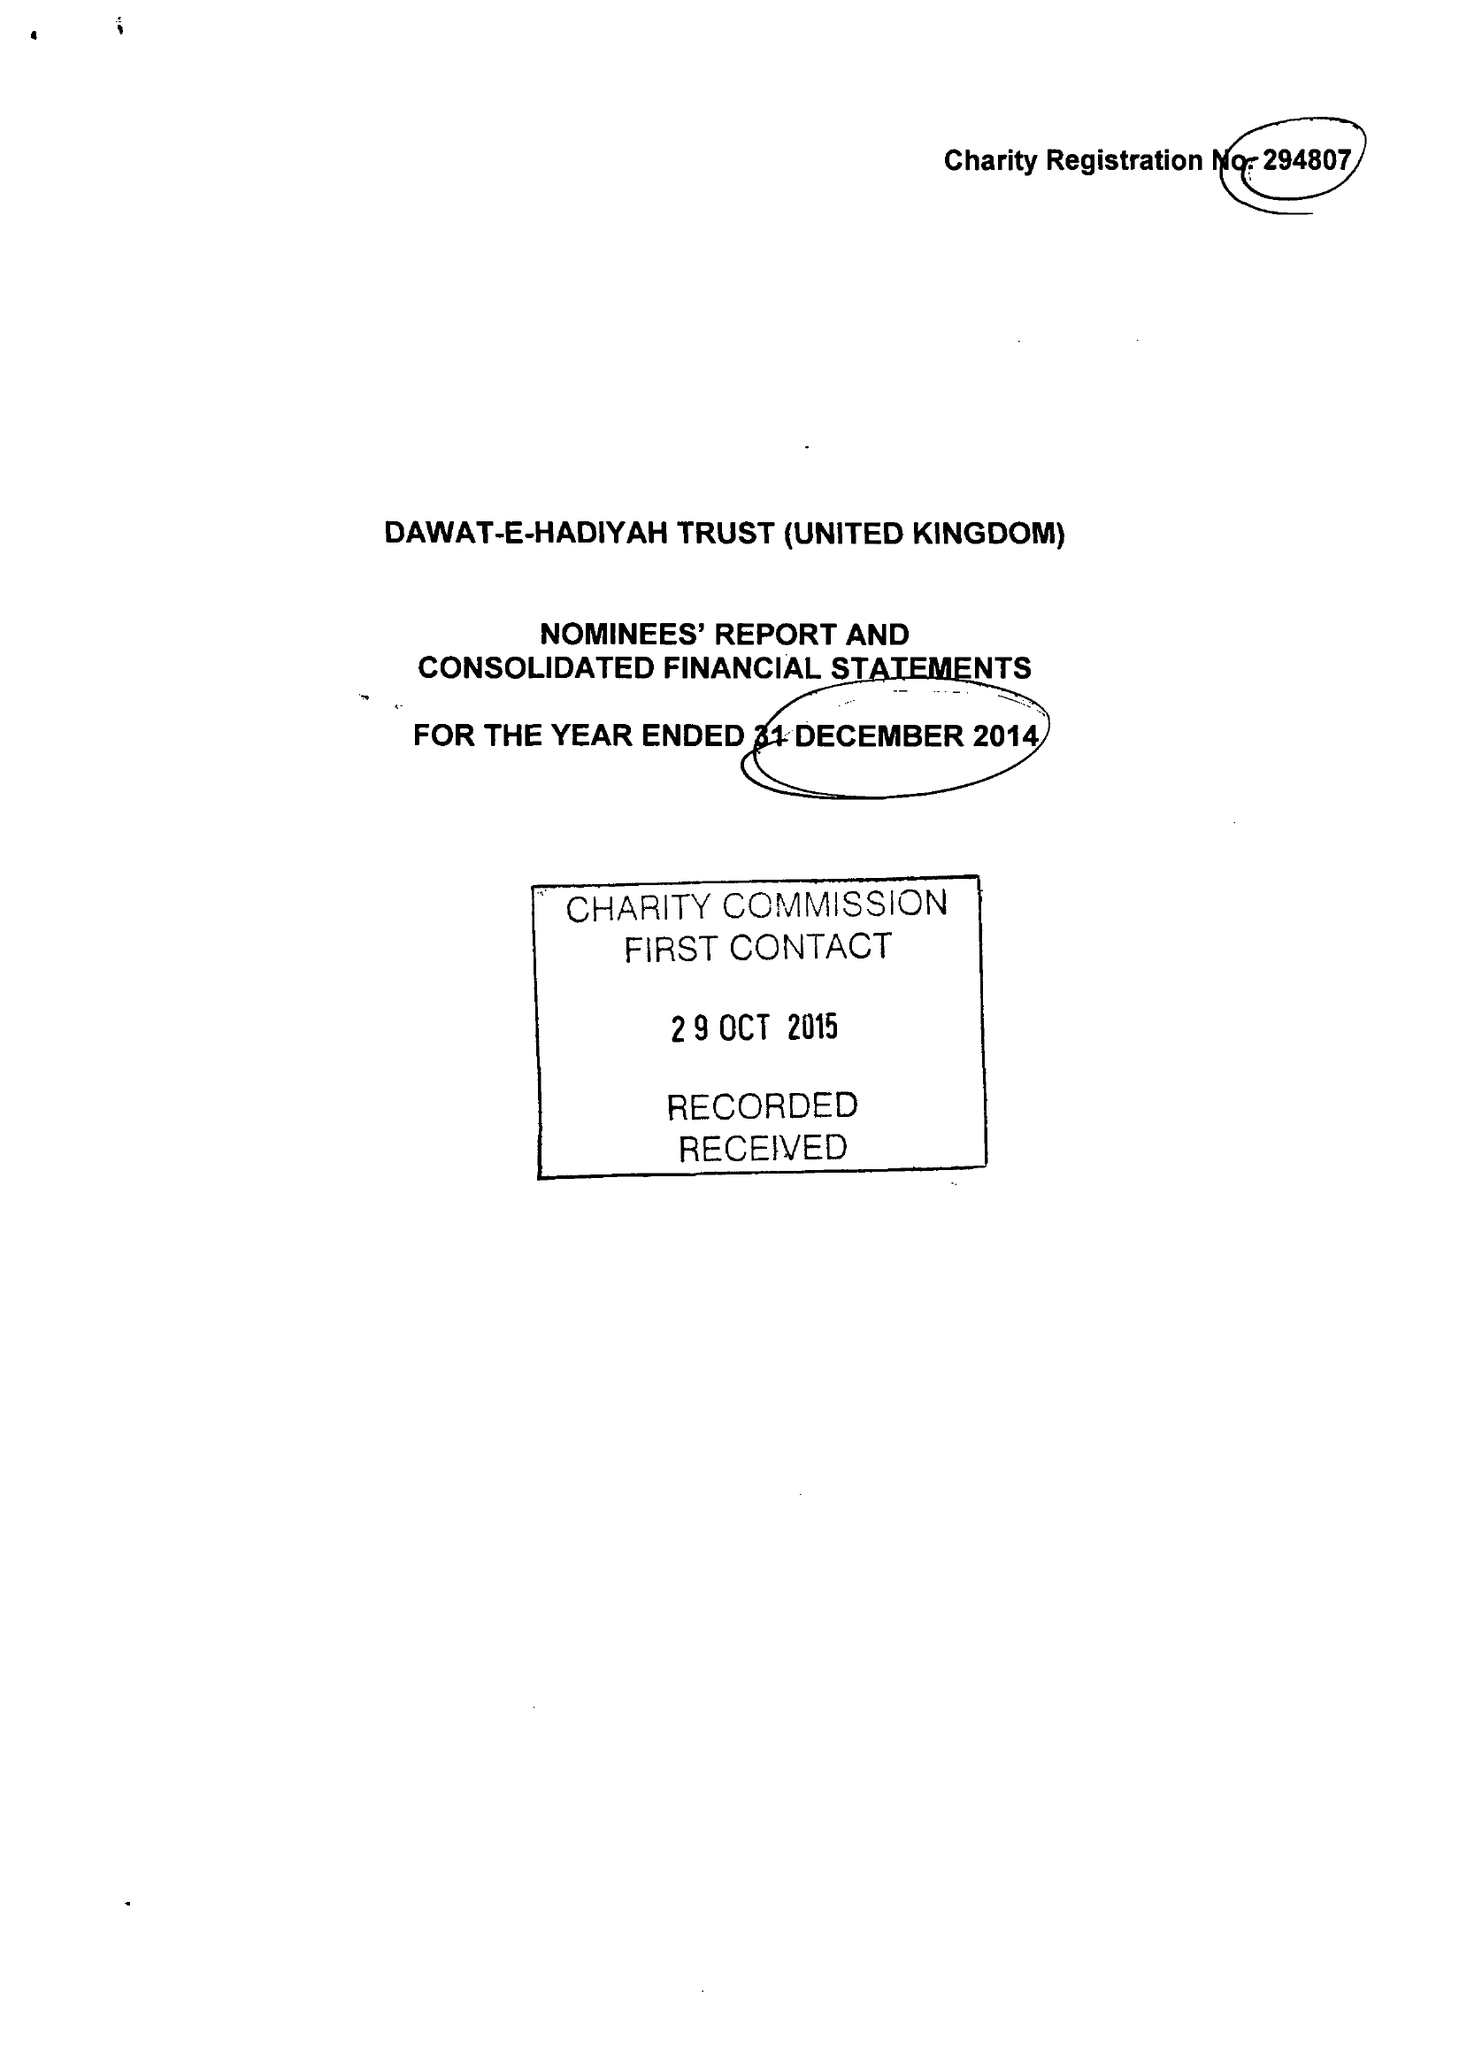What is the value for the address__post_town?
Answer the question using a single word or phrase. GREENFORD 